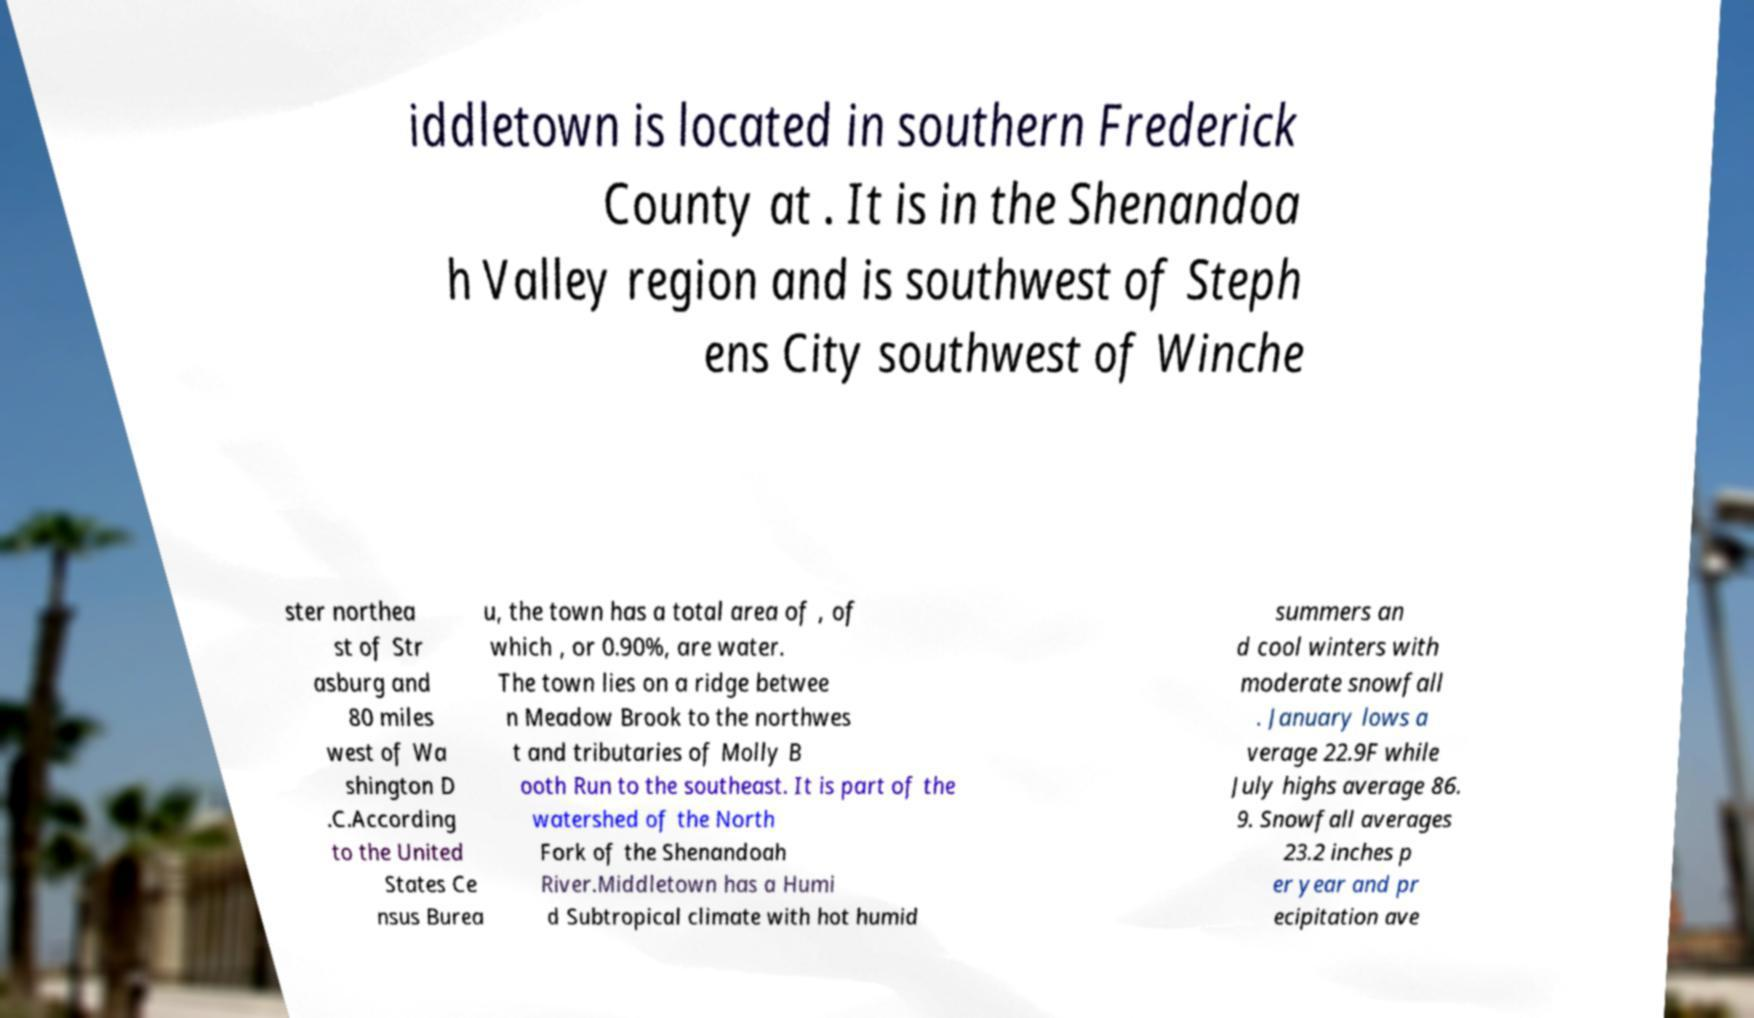Could you assist in decoding the text presented in this image and type it out clearly? iddletown is located in southern Frederick County at . It is in the Shenandoa h Valley region and is southwest of Steph ens City southwest of Winche ster northea st of Str asburg and 80 miles west of Wa shington D .C.According to the United States Ce nsus Burea u, the town has a total area of , of which , or 0.90%, are water. The town lies on a ridge betwee n Meadow Brook to the northwes t and tributaries of Molly B ooth Run to the southeast. It is part of the watershed of the North Fork of the Shenandoah River.Middletown has a Humi d Subtropical climate with hot humid summers an d cool winters with moderate snowfall . January lows a verage 22.9F while July highs average 86. 9. Snowfall averages 23.2 inches p er year and pr ecipitation ave 